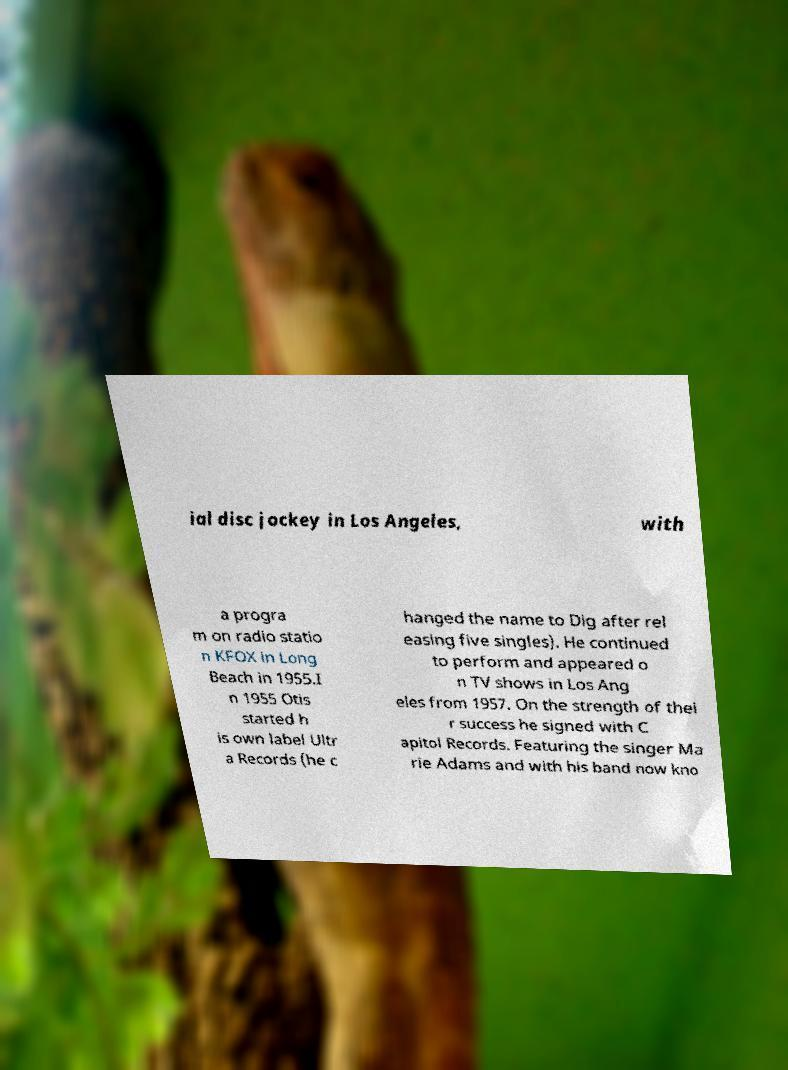There's text embedded in this image that I need extracted. Can you transcribe it verbatim? ial disc jockey in Los Angeles, with a progra m on radio statio n KFOX in Long Beach in 1955.I n 1955 Otis started h is own label Ultr a Records (he c hanged the name to Dig after rel easing five singles). He continued to perform and appeared o n TV shows in Los Ang eles from 1957. On the strength of thei r success he signed with C apitol Records. Featuring the singer Ma rie Adams and with his band now kno 